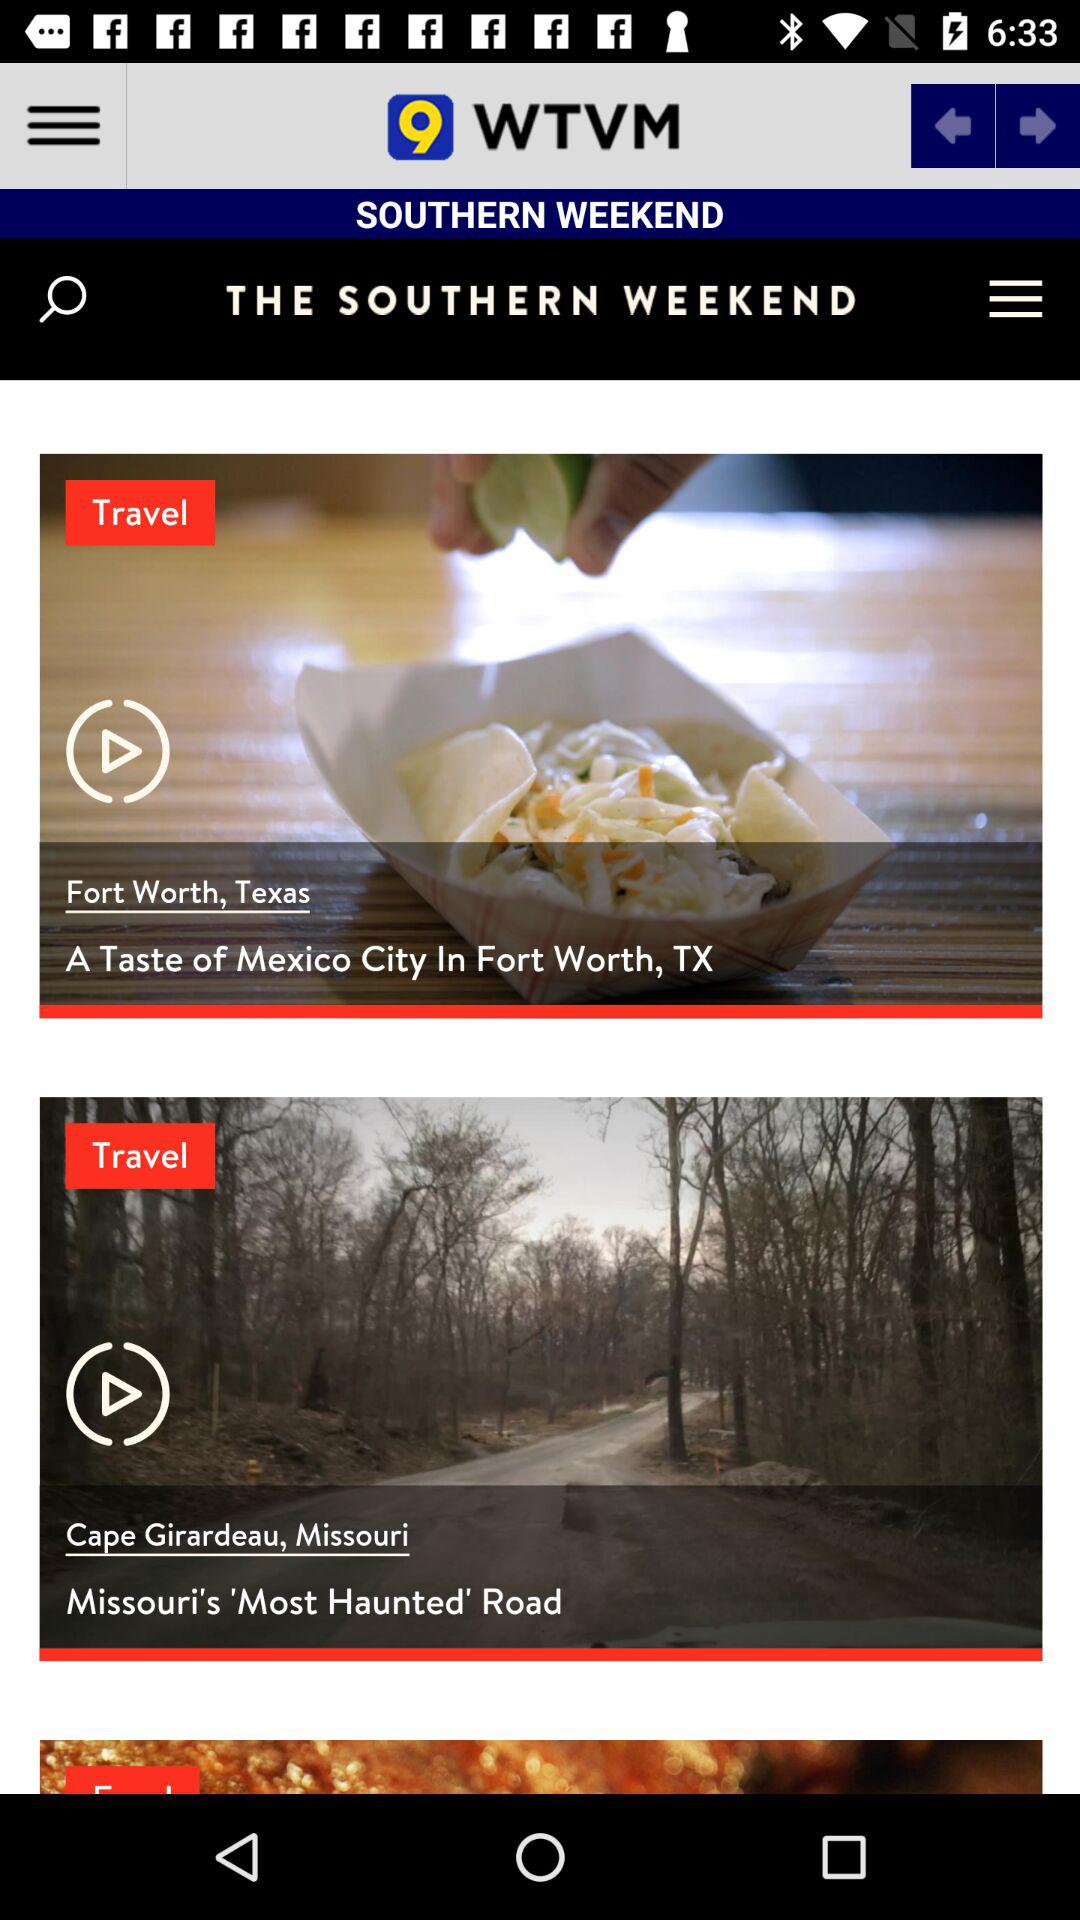What is the name of the application? The name of the application is "WTVM". 